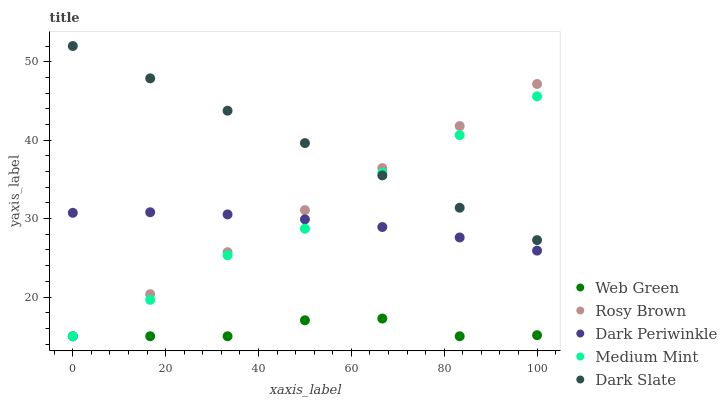Does Web Green have the minimum area under the curve?
Answer yes or no. Yes. Does Dark Slate have the maximum area under the curve?
Answer yes or no. Yes. Does Rosy Brown have the minimum area under the curve?
Answer yes or no. No. Does Rosy Brown have the maximum area under the curve?
Answer yes or no. No. Is Rosy Brown the smoothest?
Answer yes or no. Yes. Is Medium Mint the roughest?
Answer yes or no. Yes. Is Dark Slate the smoothest?
Answer yes or no. No. Is Dark Slate the roughest?
Answer yes or no. No. Does Medium Mint have the lowest value?
Answer yes or no. Yes. Does Dark Slate have the lowest value?
Answer yes or no. No. Does Dark Slate have the highest value?
Answer yes or no. Yes. Does Rosy Brown have the highest value?
Answer yes or no. No. Is Web Green less than Dark Periwinkle?
Answer yes or no. Yes. Is Dark Slate greater than Dark Periwinkle?
Answer yes or no. Yes. Does Dark Periwinkle intersect Rosy Brown?
Answer yes or no. Yes. Is Dark Periwinkle less than Rosy Brown?
Answer yes or no. No. Is Dark Periwinkle greater than Rosy Brown?
Answer yes or no. No. Does Web Green intersect Dark Periwinkle?
Answer yes or no. No. 